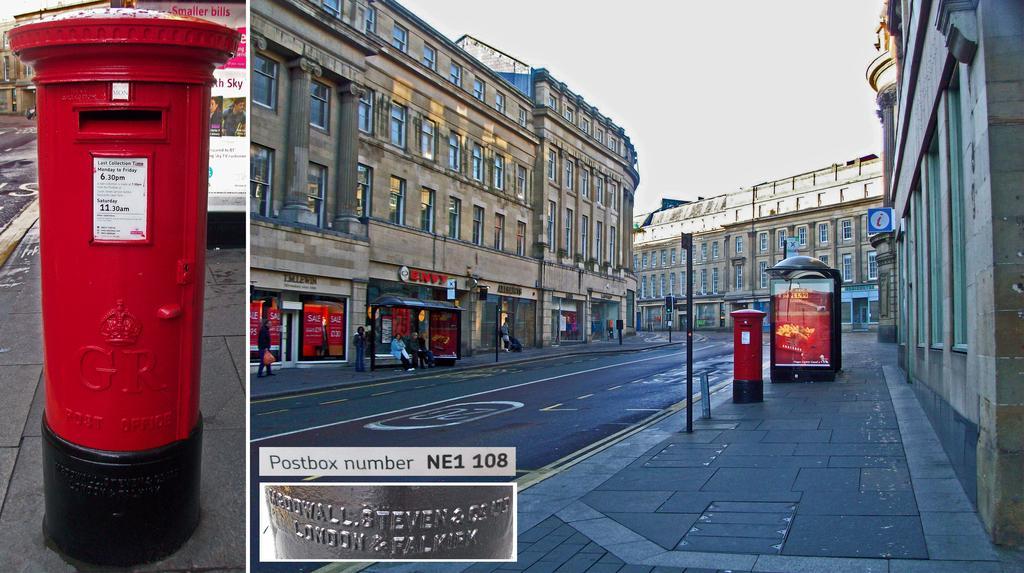In one or two sentences, can you explain what this image depicts? In this image there is collage of 2 images. On the right side there are buildings, there are persons sitting and walking and there is a post box which is red in colour. On the left side of the image there is a post box which is red in colour with some text written on it and in the background there is a building and there is a board with some text written on it and on the right side of the image in the front there is a box with some text written on it. 